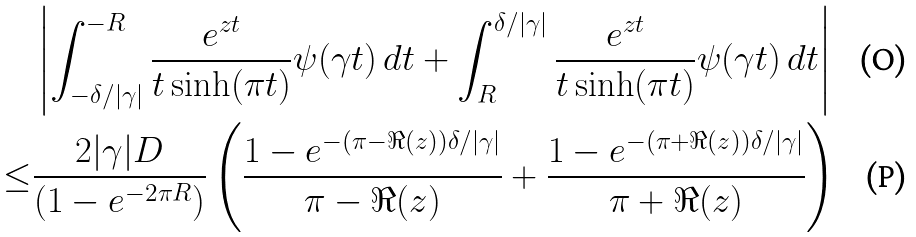<formula> <loc_0><loc_0><loc_500><loc_500>& \left | \int _ { - \delta / | \gamma | } ^ { - R } \frac { e ^ { z t } } { t \sinh ( \pi t ) } \psi ( \gamma t ) \, d t + \int _ { R } ^ { \delta / | \gamma | } \frac { e ^ { z t } } { t \sinh ( \pi t ) } \psi ( \gamma t ) \, d t \right | \\ \leq & \frac { 2 | \gamma | D } { ( 1 - e ^ { - 2 \pi R } ) } \left ( \frac { 1 - e ^ { - ( \pi - \Re ( z ) ) \delta / | \gamma | } } { \pi - \Re ( z ) } + \frac { 1 - e ^ { - ( \pi + \Re ( z ) ) \delta / | \gamma | } } { \pi + \Re ( z ) } \right )</formula> 